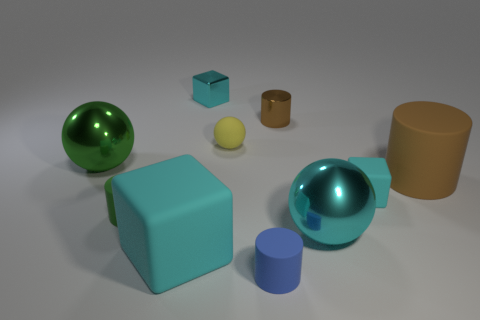Besides the cyan cube, how many other objects are in the image, and can you describe them? In addition to the cyan cube, there are five other objects: a large green glossy sphere, a small pale yellow sphere, a small shiny cyan cylinder, a larger matte green cylinder, and a large tan cylinder. Each object has distinct material qualities and colors.  Is there any object that looks out of place or different from the others? The small pale yellow sphere stands out due to its size and muted color compared to the more vivid hues and varied shapes of the other objects. 